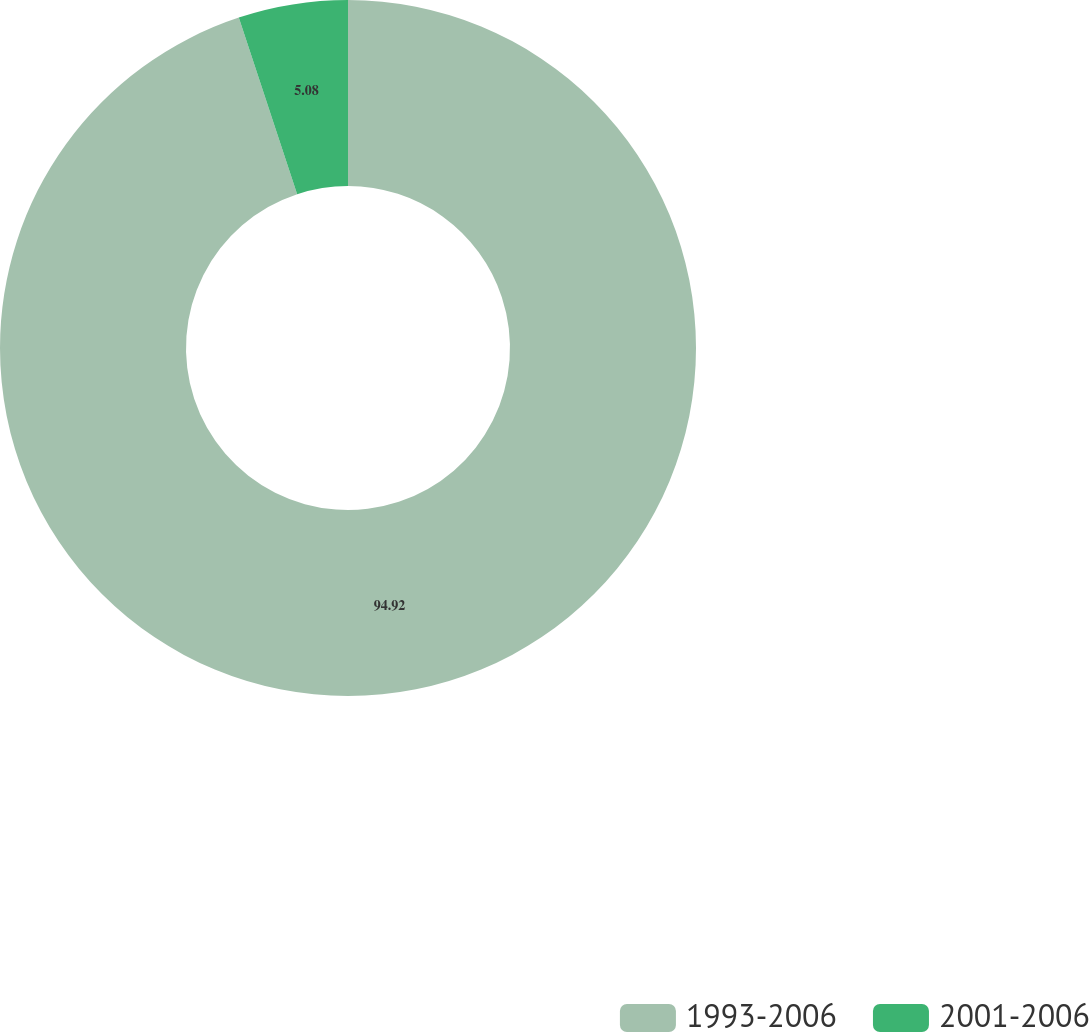Convert chart to OTSL. <chart><loc_0><loc_0><loc_500><loc_500><pie_chart><fcel>1993-2006<fcel>2001-2006<nl><fcel>94.92%<fcel>5.08%<nl></chart> 